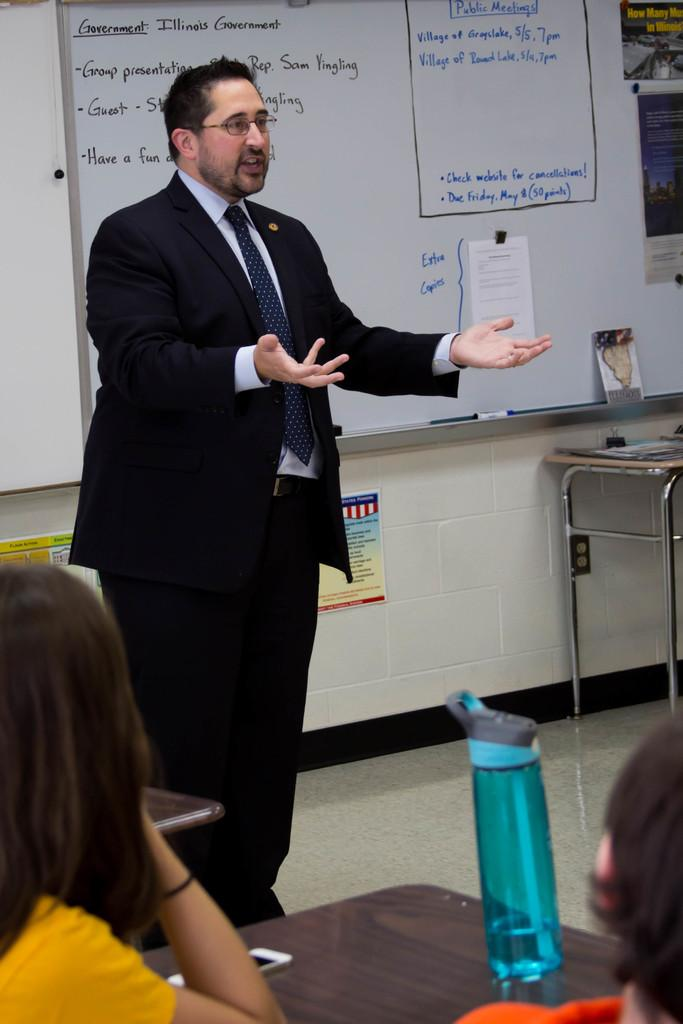<image>
Write a terse but informative summary of the picture. A man standing in front of a whiteboard with topics about Government 